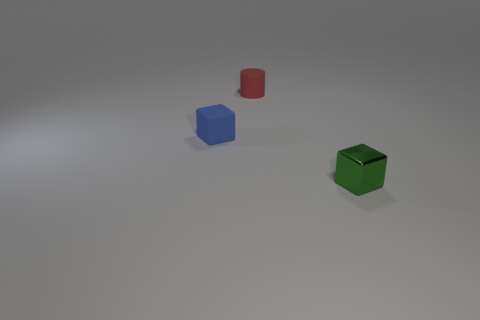Does the tiny cylinder have the same color as the tiny block that is to the left of the shiny block?
Your answer should be very brief. No. How many other objects are the same size as the blue thing?
Your answer should be very brief. 2. What is the shape of the tiny object that is in front of the cube that is left of the small block to the right of the blue thing?
Ensure brevity in your answer.  Cube. There is a blue block; is its size the same as the block in front of the tiny blue rubber cube?
Ensure brevity in your answer.  Yes. There is a small thing that is both to the left of the small green shiny thing and on the right side of the tiny blue thing; what color is it?
Your answer should be compact. Red. How many other things are the same shape as the green object?
Your response must be concise. 1. There is a small rubber object behind the blue object; does it have the same color as the small block that is behind the green cube?
Your response must be concise. No. There is a matte object that is behind the blue block; is its size the same as the cube that is to the right of the small red rubber object?
Your answer should be very brief. Yes. Are there any other things that are made of the same material as the small red thing?
Your answer should be compact. Yes. What material is the block that is to the left of the small matte thing to the right of the tiny cube behind the green shiny cube?
Offer a terse response. Rubber. 